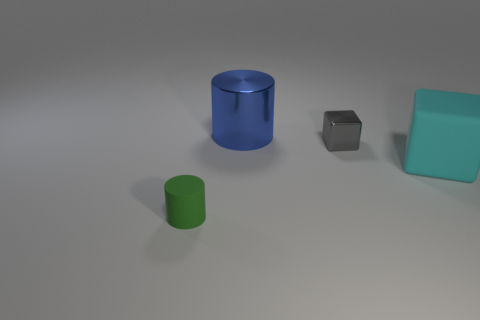What size is the shiny object that is the same shape as the large matte object?
Ensure brevity in your answer.  Small. The cyan rubber thing that is behind the tiny green matte object in front of the cyan matte thing is what shape?
Keep it short and to the point. Cube. How many green things are either tiny rubber objects or large rubber cubes?
Give a very brief answer. 1. The big cylinder has what color?
Make the answer very short. Blue. Do the blue object and the green matte cylinder have the same size?
Provide a succinct answer. No. Is there any other thing that has the same shape as the large rubber object?
Provide a succinct answer. Yes. Is the material of the large cyan block the same as the block left of the large cyan cube?
Offer a terse response. No. There is a small object behind the tiny matte cylinder; does it have the same color as the big matte thing?
Provide a succinct answer. No. How many matte objects are behind the green rubber cylinder and to the left of the small metal cube?
Keep it short and to the point. 0. What number of other things are there of the same material as the small gray cube
Offer a terse response. 1. 